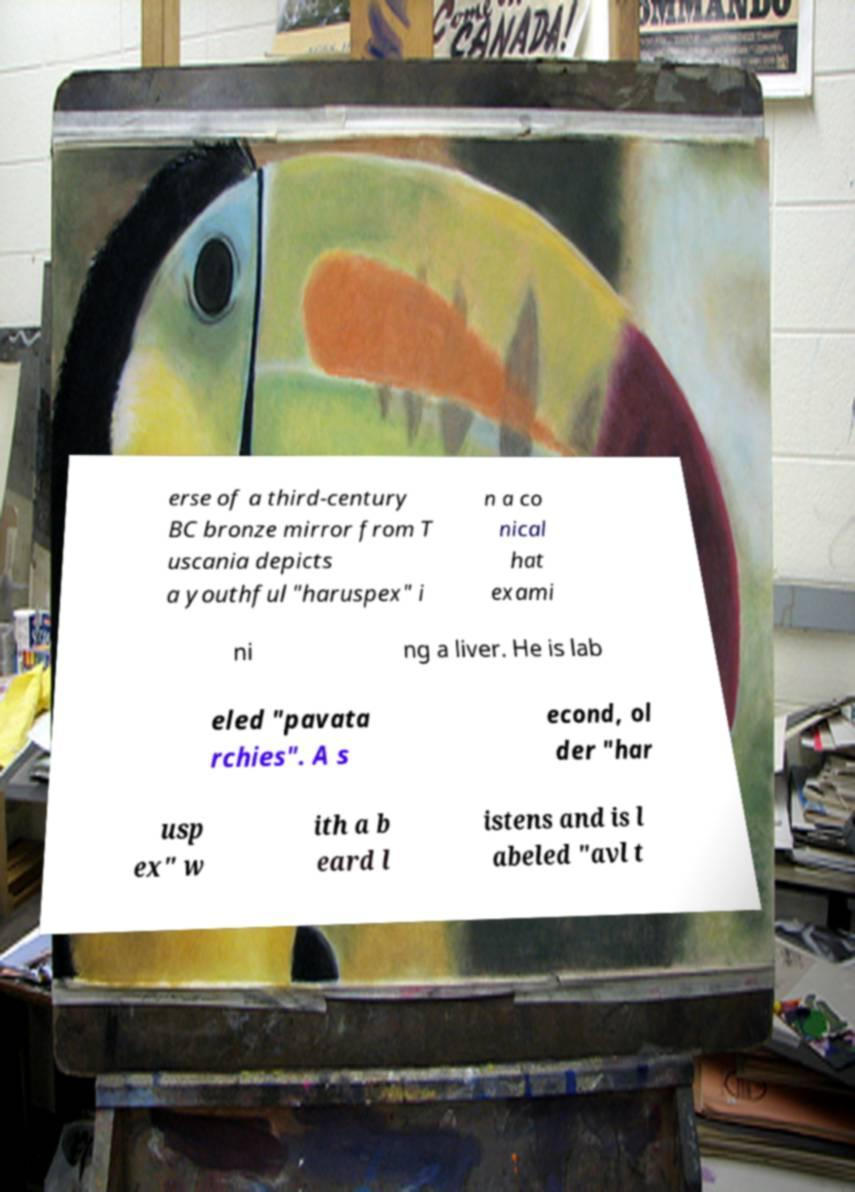Can you read and provide the text displayed in the image?This photo seems to have some interesting text. Can you extract and type it out for me? erse of a third-century BC bronze mirror from T uscania depicts a youthful "haruspex" i n a co nical hat exami ni ng a liver. He is lab eled "pavata rchies". A s econd, ol der "har usp ex" w ith a b eard l istens and is l abeled "avl t 